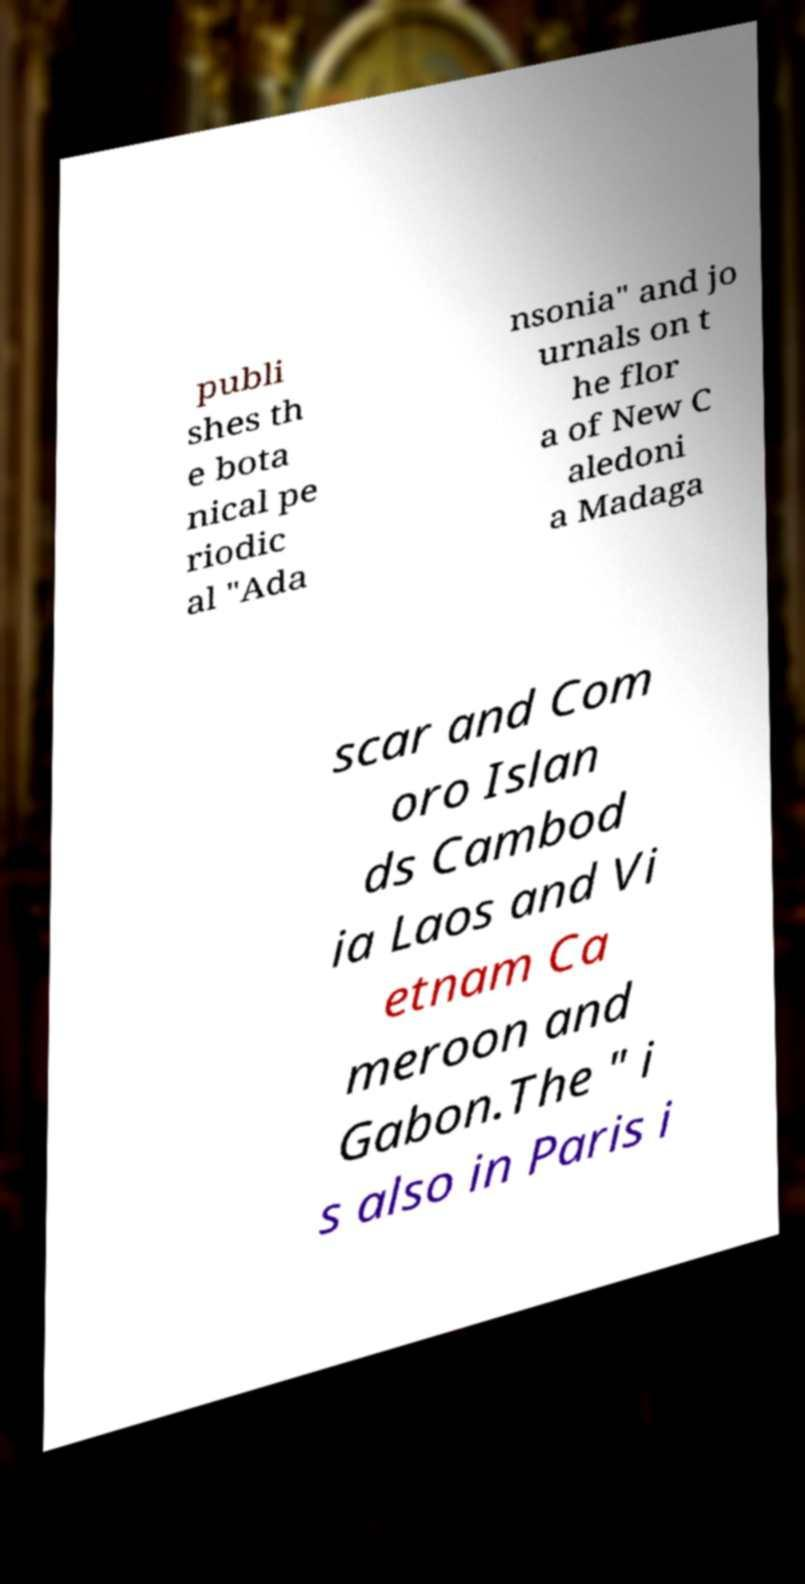Could you assist in decoding the text presented in this image and type it out clearly? publi shes th e bota nical pe riodic al "Ada nsonia" and jo urnals on t he flor a of New C aledoni a Madaga scar and Com oro Islan ds Cambod ia Laos and Vi etnam Ca meroon and Gabon.The " i s also in Paris i 